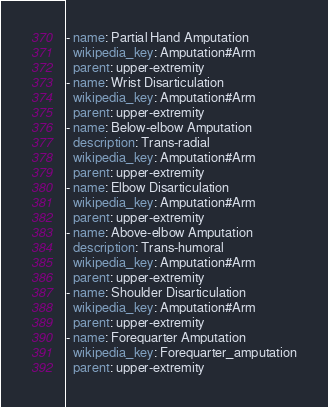<code> <loc_0><loc_0><loc_500><loc_500><_YAML_>- name: Partial Hand Amputation
  wikipedia_key: Amputation#Arm
  parent: upper-extremity
- name: Wrist Disarticulation
  wikipedia_key: Amputation#Arm
  parent: upper-extremity
- name: Below-elbow Amputation
  description: Trans-radial
  wikipedia_key: Amputation#Arm
  parent: upper-extremity
- name: Elbow Disarticulation
  wikipedia_key: Amputation#Arm
  parent: upper-extremity
- name: Above-elbow Amputation
  description: Trans-humoral
  wikipedia_key: Amputation#Arm
  parent: upper-extremity
- name: Shoulder Disarticulation
  wikipedia_key: Amputation#Arm
  parent: upper-extremity
- name: Forequarter Amputation
  wikipedia_key: Forequarter_amputation
  parent: upper-extremity
</code> 